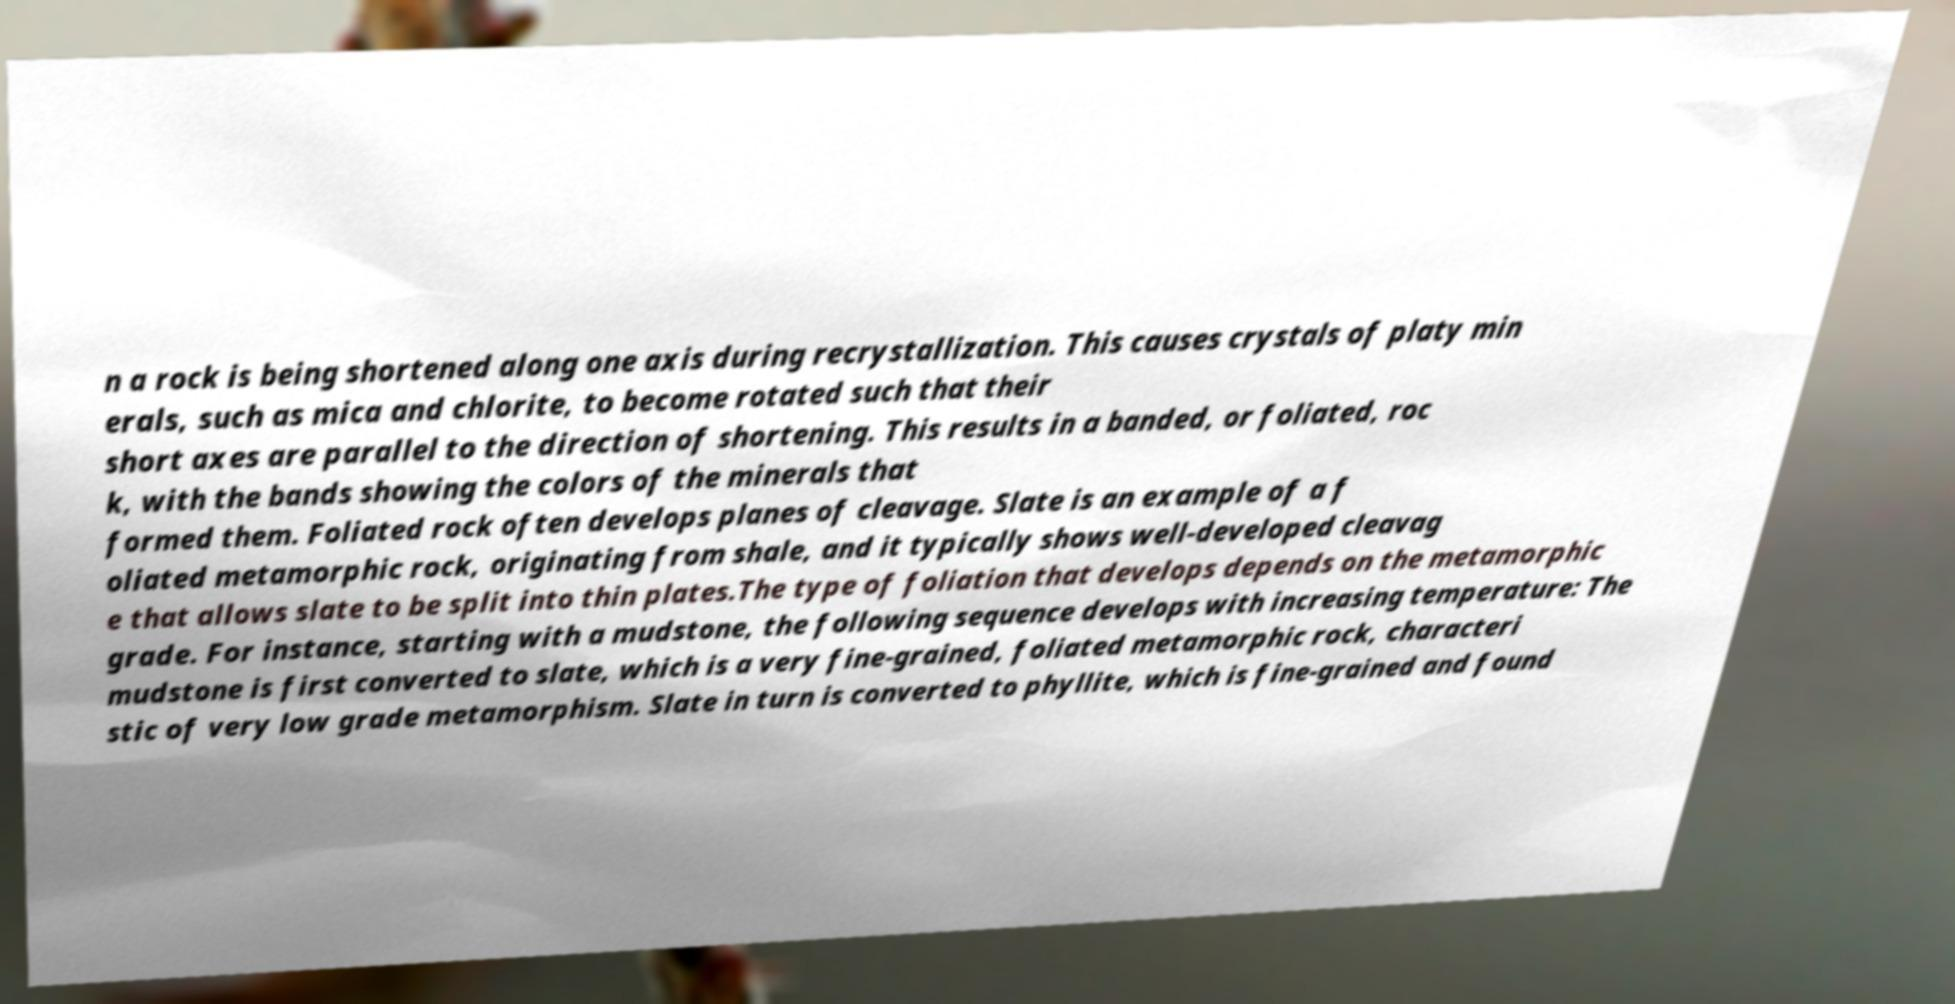Can you accurately transcribe the text from the provided image for me? n a rock is being shortened along one axis during recrystallization. This causes crystals of platy min erals, such as mica and chlorite, to become rotated such that their short axes are parallel to the direction of shortening. This results in a banded, or foliated, roc k, with the bands showing the colors of the minerals that formed them. Foliated rock often develops planes of cleavage. Slate is an example of a f oliated metamorphic rock, originating from shale, and it typically shows well-developed cleavag e that allows slate to be split into thin plates.The type of foliation that develops depends on the metamorphic grade. For instance, starting with a mudstone, the following sequence develops with increasing temperature: The mudstone is first converted to slate, which is a very fine-grained, foliated metamorphic rock, characteri stic of very low grade metamorphism. Slate in turn is converted to phyllite, which is fine-grained and found 